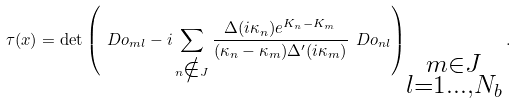Convert formula to latex. <formula><loc_0><loc_0><loc_500><loc_500>\tau ( x ) = \det \left ( \ D o _ { m l } - i \sum _ { n \notin { J } } \frac { \Delta ( i \kappa _ { n } ) e ^ { K _ { n } - K _ { m } } } { ( \kappa _ { n } - \kappa _ { m } ) \Delta ^ { \prime } ( i \kappa _ { m } ) } \ D o _ { n l } \right ) _ { \substack { m \in { J } \\ { l = 1 } { \dots , N _ { b } } } } .</formula> 